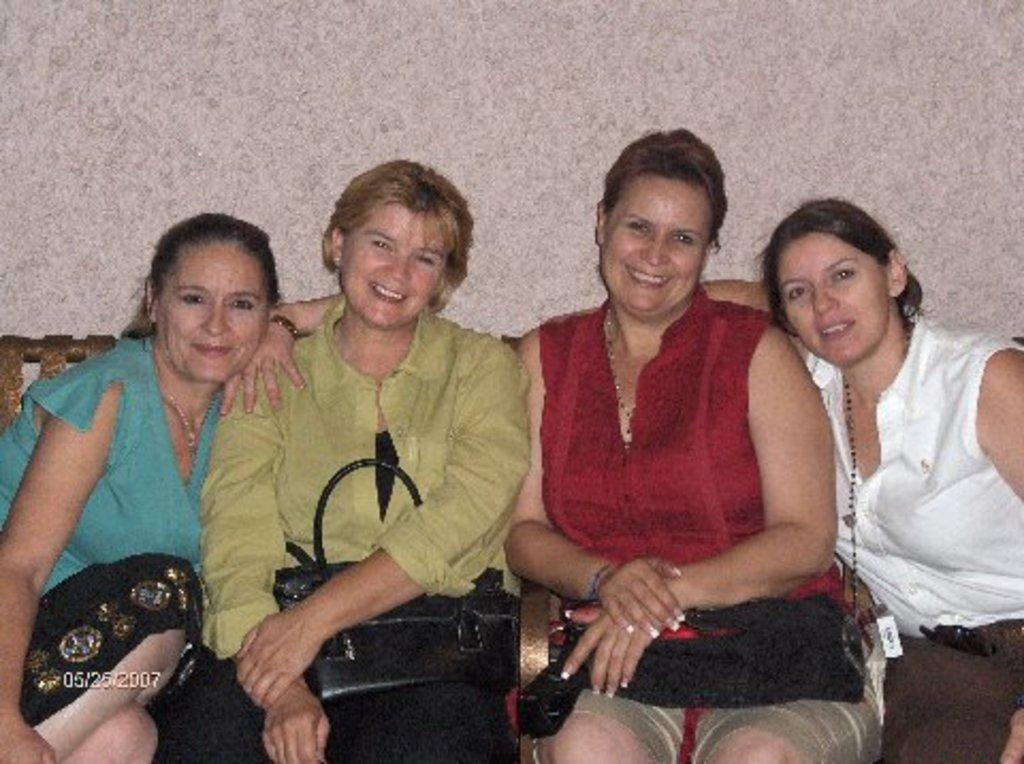What are the persons in the image doing? The persons in the image are sitting on a chair. What are the persons holding while sitting on the chair? The persons are holding bags. What can be seen in the background of the image? There is a wall in the background of the image. What type of bike is locked to the wall in the image? There is no bike present in the image; it only features persons sitting on a chair and holding bags, with a wall in the background. 